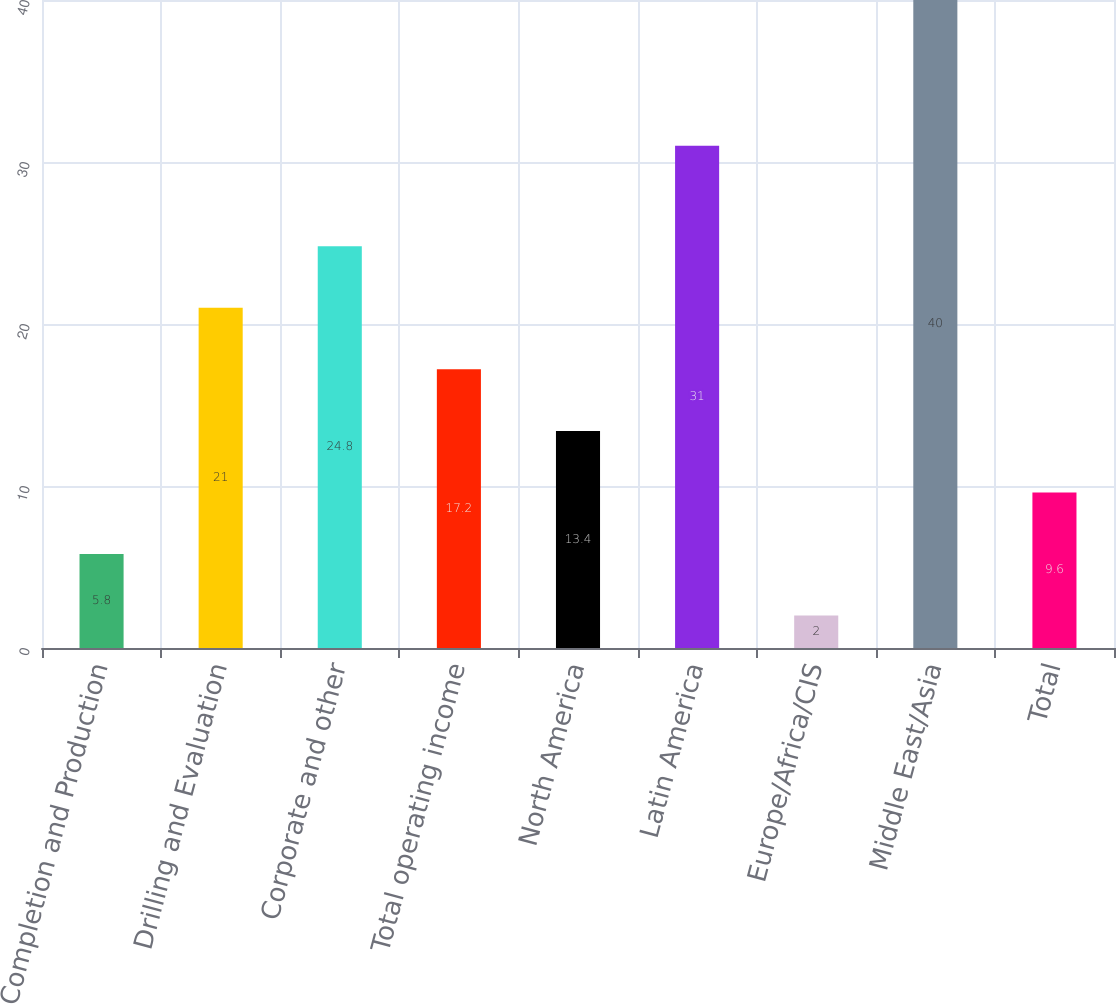Convert chart. <chart><loc_0><loc_0><loc_500><loc_500><bar_chart><fcel>Completion and Production<fcel>Drilling and Evaluation<fcel>Corporate and other<fcel>Total operating income<fcel>North America<fcel>Latin America<fcel>Europe/Africa/CIS<fcel>Middle East/Asia<fcel>Total<nl><fcel>5.8<fcel>21<fcel>24.8<fcel>17.2<fcel>13.4<fcel>31<fcel>2<fcel>40<fcel>9.6<nl></chart> 